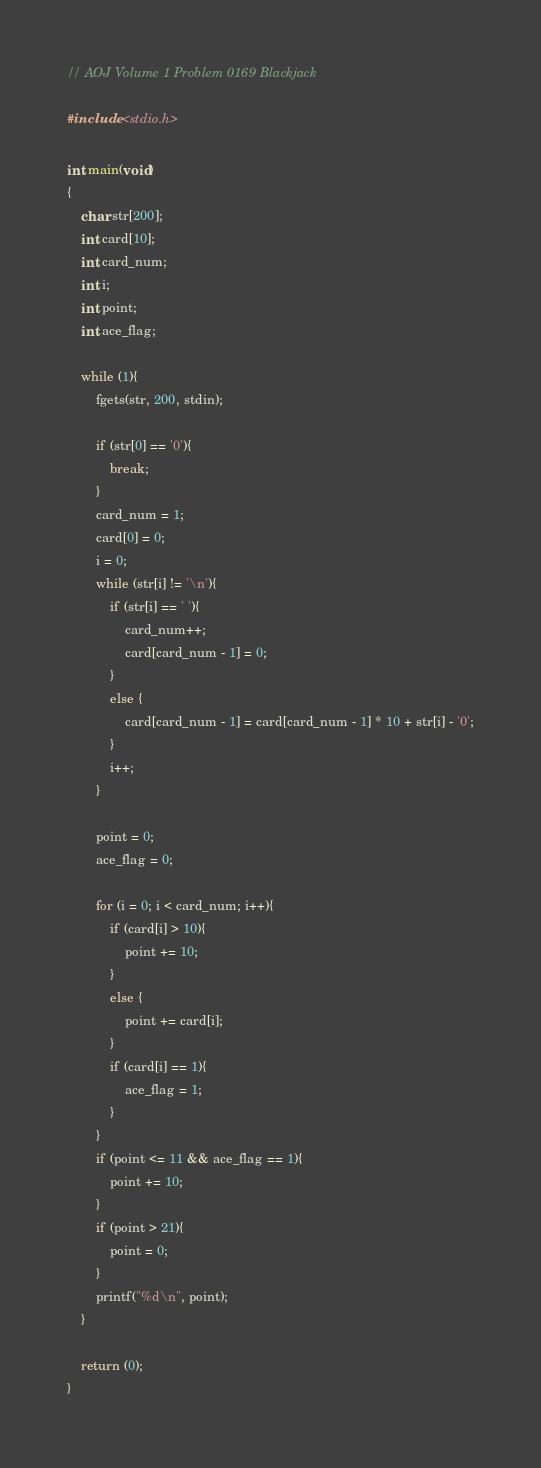<code> <loc_0><loc_0><loc_500><loc_500><_C_>// AOJ Volume 1 Problem 0169 Blackjack

#include <stdio.h>

int main(void)
{
    char str[200];
    int card[10];
    int card_num;
    int i;
    int point;
    int ace_flag;

    while (1){
        fgets(str, 200, stdin);
        
        if (str[0] == '0'){
            break;
        }
        card_num = 1;
        card[0] = 0;
        i = 0;
        while (str[i] != '\n'){
            if (str[i] == ' '){
                card_num++;
                card[card_num - 1] = 0;
            }
            else {
                card[card_num - 1] = card[card_num - 1] * 10 + str[i] - '0';
            }
            i++;
        }
        
        point = 0;
        ace_flag = 0;
        
        for (i = 0; i < card_num; i++){
            if (card[i] > 10){
                point += 10;
            }
            else {
                point += card[i];
            }
            if (card[i] == 1){
                ace_flag = 1;
            }
        }
        if (point <= 11 && ace_flag == 1){
            point += 10;
        }
        if (point > 21){
            point = 0;
        }
        printf("%d\n", point);
    }
    
    return (0);
}</code> 